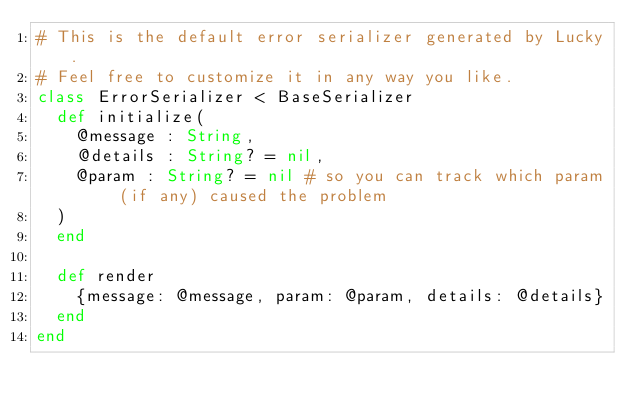<code> <loc_0><loc_0><loc_500><loc_500><_Crystal_># This is the default error serializer generated by Lucky.
# Feel free to customize it in any way you like.
class ErrorSerializer < BaseSerializer
  def initialize(
    @message : String,
    @details : String? = nil,
    @param : String? = nil # so you can track which param (if any) caused the problem
  )
  end

  def render
    {message: @message, param: @param, details: @details}
  end
end
</code> 